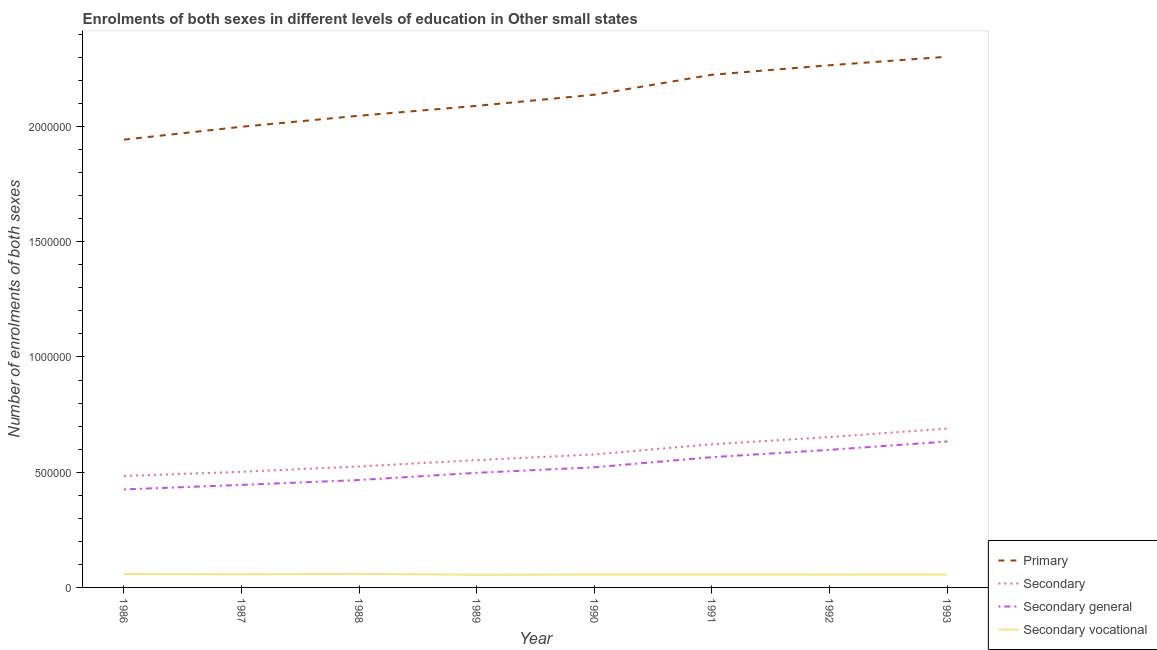Does the line corresponding to number of enrolments in primary education intersect with the line corresponding to number of enrolments in secondary education?
Your answer should be very brief. No. What is the number of enrolments in secondary education in 1989?
Your response must be concise. 5.52e+05. Across all years, what is the maximum number of enrolments in primary education?
Keep it short and to the point. 2.30e+06. Across all years, what is the minimum number of enrolments in secondary general education?
Keep it short and to the point. 4.25e+05. In which year was the number of enrolments in secondary vocational education maximum?
Your answer should be compact. 1988. What is the total number of enrolments in secondary education in the graph?
Ensure brevity in your answer.  4.60e+06. What is the difference between the number of enrolments in secondary education in 1987 and that in 1990?
Ensure brevity in your answer.  -7.55e+04. What is the difference between the number of enrolments in primary education in 1989 and the number of enrolments in secondary vocational education in 1987?
Your response must be concise. 2.03e+06. What is the average number of enrolments in secondary vocational education per year?
Your response must be concise. 5.65e+04. In the year 1988, what is the difference between the number of enrolments in primary education and number of enrolments in secondary general education?
Your answer should be compact. 1.58e+06. In how many years, is the number of enrolments in secondary education greater than 2300000?
Keep it short and to the point. 0. What is the ratio of the number of enrolments in secondary general education in 1989 to that in 1990?
Keep it short and to the point. 0.95. What is the difference between the highest and the second highest number of enrolments in primary education?
Keep it short and to the point. 3.69e+04. What is the difference between the highest and the lowest number of enrolments in secondary education?
Your response must be concise. 2.05e+05. Is it the case that in every year, the sum of the number of enrolments in secondary general education and number of enrolments in secondary education is greater than the sum of number of enrolments in primary education and number of enrolments in secondary vocational education?
Make the answer very short. No. How many lines are there?
Keep it short and to the point. 4. Are the values on the major ticks of Y-axis written in scientific E-notation?
Keep it short and to the point. No. Does the graph contain grids?
Ensure brevity in your answer.  No. How many legend labels are there?
Your answer should be very brief. 4. What is the title of the graph?
Provide a short and direct response. Enrolments of both sexes in different levels of education in Other small states. Does "Plant species" appear as one of the legend labels in the graph?
Keep it short and to the point. No. What is the label or title of the X-axis?
Keep it short and to the point. Year. What is the label or title of the Y-axis?
Keep it short and to the point. Number of enrolments of both sexes. What is the Number of enrolments of both sexes in Primary in 1986?
Your answer should be compact. 1.94e+06. What is the Number of enrolments of both sexes in Secondary in 1986?
Provide a succinct answer. 4.84e+05. What is the Number of enrolments of both sexes of Secondary general in 1986?
Provide a short and direct response. 4.25e+05. What is the Number of enrolments of both sexes in Secondary vocational in 1986?
Your answer should be compact. 5.83e+04. What is the Number of enrolments of both sexes in Primary in 1987?
Provide a short and direct response. 2.00e+06. What is the Number of enrolments of both sexes of Secondary in 1987?
Provide a short and direct response. 5.02e+05. What is the Number of enrolments of both sexes of Secondary general in 1987?
Your answer should be compact. 4.45e+05. What is the Number of enrolments of both sexes of Secondary vocational in 1987?
Your response must be concise. 5.69e+04. What is the Number of enrolments of both sexes in Primary in 1988?
Your response must be concise. 2.05e+06. What is the Number of enrolments of both sexes of Secondary in 1988?
Your answer should be compact. 5.25e+05. What is the Number of enrolments of both sexes of Secondary general in 1988?
Offer a terse response. 4.66e+05. What is the Number of enrolments of both sexes of Secondary vocational in 1988?
Provide a short and direct response. 5.89e+04. What is the Number of enrolments of both sexes in Primary in 1989?
Keep it short and to the point. 2.09e+06. What is the Number of enrolments of both sexes in Secondary in 1989?
Your response must be concise. 5.52e+05. What is the Number of enrolments of both sexes in Secondary general in 1989?
Your answer should be compact. 4.97e+05. What is the Number of enrolments of both sexes of Secondary vocational in 1989?
Your answer should be very brief. 5.49e+04. What is the Number of enrolments of both sexes in Primary in 1990?
Provide a succinct answer. 2.14e+06. What is the Number of enrolments of both sexes of Secondary in 1990?
Keep it short and to the point. 5.77e+05. What is the Number of enrolments of both sexes of Secondary general in 1990?
Your answer should be compact. 5.21e+05. What is the Number of enrolments of both sexes of Secondary vocational in 1990?
Your answer should be compact. 5.59e+04. What is the Number of enrolments of both sexes in Primary in 1991?
Provide a succinct answer. 2.22e+06. What is the Number of enrolments of both sexes in Secondary in 1991?
Offer a terse response. 6.21e+05. What is the Number of enrolments of both sexes in Secondary general in 1991?
Your answer should be compact. 5.65e+05. What is the Number of enrolments of both sexes in Secondary vocational in 1991?
Keep it short and to the point. 5.59e+04. What is the Number of enrolments of both sexes of Primary in 1992?
Your answer should be very brief. 2.27e+06. What is the Number of enrolments of both sexes in Secondary in 1992?
Keep it short and to the point. 6.53e+05. What is the Number of enrolments of both sexes of Secondary general in 1992?
Provide a short and direct response. 5.97e+05. What is the Number of enrolments of both sexes in Secondary vocational in 1992?
Offer a terse response. 5.57e+04. What is the Number of enrolments of both sexes of Primary in 1993?
Your answer should be very brief. 2.30e+06. What is the Number of enrolments of both sexes of Secondary in 1993?
Make the answer very short. 6.89e+05. What is the Number of enrolments of both sexes of Secondary general in 1993?
Your response must be concise. 6.33e+05. What is the Number of enrolments of both sexes of Secondary vocational in 1993?
Offer a very short reply. 5.59e+04. Across all years, what is the maximum Number of enrolments of both sexes in Primary?
Your answer should be compact. 2.30e+06. Across all years, what is the maximum Number of enrolments of both sexes of Secondary?
Your answer should be compact. 6.89e+05. Across all years, what is the maximum Number of enrolments of both sexes in Secondary general?
Give a very brief answer. 6.33e+05. Across all years, what is the maximum Number of enrolments of both sexes in Secondary vocational?
Give a very brief answer. 5.89e+04. Across all years, what is the minimum Number of enrolments of both sexes of Primary?
Provide a succinct answer. 1.94e+06. Across all years, what is the minimum Number of enrolments of both sexes of Secondary?
Ensure brevity in your answer.  4.84e+05. Across all years, what is the minimum Number of enrolments of both sexes of Secondary general?
Offer a terse response. 4.25e+05. Across all years, what is the minimum Number of enrolments of both sexes in Secondary vocational?
Give a very brief answer. 5.49e+04. What is the total Number of enrolments of both sexes in Primary in the graph?
Offer a very short reply. 1.70e+07. What is the total Number of enrolments of both sexes in Secondary in the graph?
Keep it short and to the point. 4.60e+06. What is the total Number of enrolments of both sexes of Secondary general in the graph?
Your response must be concise. 4.15e+06. What is the total Number of enrolments of both sexes in Secondary vocational in the graph?
Your answer should be very brief. 4.52e+05. What is the difference between the Number of enrolments of both sexes of Primary in 1986 and that in 1987?
Your answer should be very brief. -5.59e+04. What is the difference between the Number of enrolments of both sexes of Secondary in 1986 and that in 1987?
Your response must be concise. -1.81e+04. What is the difference between the Number of enrolments of both sexes in Secondary general in 1986 and that in 1987?
Give a very brief answer. -1.95e+04. What is the difference between the Number of enrolments of both sexes of Secondary vocational in 1986 and that in 1987?
Keep it short and to the point. 1404.46. What is the difference between the Number of enrolments of both sexes of Primary in 1986 and that in 1988?
Provide a short and direct response. -1.04e+05. What is the difference between the Number of enrolments of both sexes of Secondary in 1986 and that in 1988?
Keep it short and to the point. -4.14e+04. What is the difference between the Number of enrolments of both sexes of Secondary general in 1986 and that in 1988?
Ensure brevity in your answer.  -4.08e+04. What is the difference between the Number of enrolments of both sexes of Secondary vocational in 1986 and that in 1988?
Your answer should be very brief. -603.38. What is the difference between the Number of enrolments of both sexes in Primary in 1986 and that in 1989?
Provide a short and direct response. -1.47e+05. What is the difference between the Number of enrolments of both sexes of Secondary in 1986 and that in 1989?
Give a very brief answer. -6.87e+04. What is the difference between the Number of enrolments of both sexes of Secondary general in 1986 and that in 1989?
Your answer should be compact. -7.21e+04. What is the difference between the Number of enrolments of both sexes in Secondary vocational in 1986 and that in 1989?
Offer a terse response. 3339.44. What is the difference between the Number of enrolments of both sexes of Primary in 1986 and that in 1990?
Ensure brevity in your answer.  -1.95e+05. What is the difference between the Number of enrolments of both sexes of Secondary in 1986 and that in 1990?
Give a very brief answer. -9.36e+04. What is the difference between the Number of enrolments of both sexes of Secondary general in 1986 and that in 1990?
Your answer should be compact. -9.60e+04. What is the difference between the Number of enrolments of both sexes of Secondary vocational in 1986 and that in 1990?
Offer a very short reply. 2395.68. What is the difference between the Number of enrolments of both sexes in Primary in 1986 and that in 1991?
Offer a terse response. -2.82e+05. What is the difference between the Number of enrolments of both sexes in Secondary in 1986 and that in 1991?
Your response must be concise. -1.38e+05. What is the difference between the Number of enrolments of both sexes of Secondary general in 1986 and that in 1991?
Your answer should be very brief. -1.40e+05. What is the difference between the Number of enrolments of both sexes of Secondary vocational in 1986 and that in 1991?
Provide a short and direct response. 2357.86. What is the difference between the Number of enrolments of both sexes of Primary in 1986 and that in 1992?
Your answer should be very brief. -3.23e+05. What is the difference between the Number of enrolments of both sexes of Secondary in 1986 and that in 1992?
Provide a succinct answer. -1.69e+05. What is the difference between the Number of enrolments of both sexes in Secondary general in 1986 and that in 1992?
Your response must be concise. -1.72e+05. What is the difference between the Number of enrolments of both sexes of Secondary vocational in 1986 and that in 1992?
Keep it short and to the point. 2622.14. What is the difference between the Number of enrolments of both sexes of Primary in 1986 and that in 1993?
Make the answer very short. -3.60e+05. What is the difference between the Number of enrolments of both sexes in Secondary in 1986 and that in 1993?
Your response must be concise. -2.05e+05. What is the difference between the Number of enrolments of both sexes in Secondary general in 1986 and that in 1993?
Your answer should be compact. -2.08e+05. What is the difference between the Number of enrolments of both sexes in Secondary vocational in 1986 and that in 1993?
Your response must be concise. 2383.9. What is the difference between the Number of enrolments of both sexes of Primary in 1987 and that in 1988?
Provide a short and direct response. -4.79e+04. What is the difference between the Number of enrolments of both sexes in Secondary in 1987 and that in 1988?
Make the answer very short. -2.33e+04. What is the difference between the Number of enrolments of both sexes of Secondary general in 1987 and that in 1988?
Offer a very short reply. -2.13e+04. What is the difference between the Number of enrolments of both sexes in Secondary vocational in 1987 and that in 1988?
Make the answer very short. -2007.84. What is the difference between the Number of enrolments of both sexes of Primary in 1987 and that in 1989?
Give a very brief answer. -9.08e+04. What is the difference between the Number of enrolments of both sexes of Secondary in 1987 and that in 1989?
Make the answer very short. -5.06e+04. What is the difference between the Number of enrolments of both sexes in Secondary general in 1987 and that in 1989?
Offer a very short reply. -5.25e+04. What is the difference between the Number of enrolments of both sexes in Secondary vocational in 1987 and that in 1989?
Your answer should be very brief. 1934.98. What is the difference between the Number of enrolments of both sexes of Primary in 1987 and that in 1990?
Keep it short and to the point. -1.39e+05. What is the difference between the Number of enrolments of both sexes of Secondary in 1987 and that in 1990?
Provide a short and direct response. -7.55e+04. What is the difference between the Number of enrolments of both sexes of Secondary general in 1987 and that in 1990?
Keep it short and to the point. -7.65e+04. What is the difference between the Number of enrolments of both sexes of Secondary vocational in 1987 and that in 1990?
Offer a very short reply. 991.21. What is the difference between the Number of enrolments of both sexes of Primary in 1987 and that in 1991?
Provide a succinct answer. -2.26e+05. What is the difference between the Number of enrolments of both sexes in Secondary in 1987 and that in 1991?
Offer a very short reply. -1.19e+05. What is the difference between the Number of enrolments of both sexes in Secondary general in 1987 and that in 1991?
Provide a short and direct response. -1.20e+05. What is the difference between the Number of enrolments of both sexes in Secondary vocational in 1987 and that in 1991?
Keep it short and to the point. 953.4. What is the difference between the Number of enrolments of both sexes in Primary in 1987 and that in 1992?
Offer a terse response. -2.67e+05. What is the difference between the Number of enrolments of both sexes in Secondary in 1987 and that in 1992?
Offer a very short reply. -1.51e+05. What is the difference between the Number of enrolments of both sexes of Secondary general in 1987 and that in 1992?
Keep it short and to the point. -1.52e+05. What is the difference between the Number of enrolments of both sexes in Secondary vocational in 1987 and that in 1992?
Provide a succinct answer. 1217.68. What is the difference between the Number of enrolments of both sexes of Primary in 1987 and that in 1993?
Offer a very short reply. -3.04e+05. What is the difference between the Number of enrolments of both sexes of Secondary in 1987 and that in 1993?
Your answer should be compact. -1.87e+05. What is the difference between the Number of enrolments of both sexes in Secondary general in 1987 and that in 1993?
Your answer should be compact. -1.88e+05. What is the difference between the Number of enrolments of both sexes of Secondary vocational in 1987 and that in 1993?
Your answer should be compact. 979.44. What is the difference between the Number of enrolments of both sexes of Primary in 1988 and that in 1989?
Offer a very short reply. -4.29e+04. What is the difference between the Number of enrolments of both sexes in Secondary in 1988 and that in 1989?
Keep it short and to the point. -2.73e+04. What is the difference between the Number of enrolments of both sexes in Secondary general in 1988 and that in 1989?
Provide a short and direct response. -3.13e+04. What is the difference between the Number of enrolments of both sexes of Secondary vocational in 1988 and that in 1989?
Make the answer very short. 3942.82. What is the difference between the Number of enrolments of both sexes in Primary in 1988 and that in 1990?
Offer a very short reply. -9.12e+04. What is the difference between the Number of enrolments of both sexes in Secondary in 1988 and that in 1990?
Provide a succinct answer. -5.22e+04. What is the difference between the Number of enrolments of both sexes of Secondary general in 1988 and that in 1990?
Provide a short and direct response. -5.52e+04. What is the difference between the Number of enrolments of both sexes of Secondary vocational in 1988 and that in 1990?
Ensure brevity in your answer.  2999.05. What is the difference between the Number of enrolments of both sexes in Primary in 1988 and that in 1991?
Ensure brevity in your answer.  -1.78e+05. What is the difference between the Number of enrolments of both sexes in Secondary in 1988 and that in 1991?
Provide a short and direct response. -9.62e+04. What is the difference between the Number of enrolments of both sexes in Secondary general in 1988 and that in 1991?
Offer a terse response. -9.92e+04. What is the difference between the Number of enrolments of both sexes in Secondary vocational in 1988 and that in 1991?
Your answer should be very brief. 2961.24. What is the difference between the Number of enrolments of both sexes in Primary in 1988 and that in 1992?
Offer a terse response. -2.19e+05. What is the difference between the Number of enrolments of both sexes in Secondary in 1988 and that in 1992?
Make the answer very short. -1.28e+05. What is the difference between the Number of enrolments of both sexes of Secondary general in 1988 and that in 1992?
Your answer should be very brief. -1.31e+05. What is the difference between the Number of enrolments of both sexes of Secondary vocational in 1988 and that in 1992?
Your answer should be very brief. 3225.52. What is the difference between the Number of enrolments of both sexes of Primary in 1988 and that in 1993?
Ensure brevity in your answer.  -2.56e+05. What is the difference between the Number of enrolments of both sexes in Secondary in 1988 and that in 1993?
Provide a succinct answer. -1.64e+05. What is the difference between the Number of enrolments of both sexes in Secondary general in 1988 and that in 1993?
Make the answer very short. -1.67e+05. What is the difference between the Number of enrolments of both sexes of Secondary vocational in 1988 and that in 1993?
Ensure brevity in your answer.  2987.28. What is the difference between the Number of enrolments of both sexes in Primary in 1989 and that in 1990?
Give a very brief answer. -4.83e+04. What is the difference between the Number of enrolments of both sexes in Secondary in 1989 and that in 1990?
Your answer should be compact. -2.49e+04. What is the difference between the Number of enrolments of both sexes of Secondary general in 1989 and that in 1990?
Your response must be concise. -2.39e+04. What is the difference between the Number of enrolments of both sexes of Secondary vocational in 1989 and that in 1990?
Your answer should be compact. -943.76. What is the difference between the Number of enrolments of both sexes of Primary in 1989 and that in 1991?
Make the answer very short. -1.35e+05. What is the difference between the Number of enrolments of both sexes in Secondary in 1989 and that in 1991?
Your answer should be very brief. -6.89e+04. What is the difference between the Number of enrolments of both sexes in Secondary general in 1989 and that in 1991?
Provide a succinct answer. -6.79e+04. What is the difference between the Number of enrolments of both sexes in Secondary vocational in 1989 and that in 1991?
Make the answer very short. -981.58. What is the difference between the Number of enrolments of both sexes in Primary in 1989 and that in 1992?
Offer a very short reply. -1.76e+05. What is the difference between the Number of enrolments of both sexes in Secondary in 1989 and that in 1992?
Offer a terse response. -1.00e+05. What is the difference between the Number of enrolments of both sexes of Secondary general in 1989 and that in 1992?
Provide a succinct answer. -9.96e+04. What is the difference between the Number of enrolments of both sexes of Secondary vocational in 1989 and that in 1992?
Provide a short and direct response. -717.3. What is the difference between the Number of enrolments of both sexes in Primary in 1989 and that in 1993?
Offer a terse response. -2.13e+05. What is the difference between the Number of enrolments of both sexes of Secondary in 1989 and that in 1993?
Offer a terse response. -1.37e+05. What is the difference between the Number of enrolments of both sexes in Secondary general in 1989 and that in 1993?
Keep it short and to the point. -1.36e+05. What is the difference between the Number of enrolments of both sexes of Secondary vocational in 1989 and that in 1993?
Your response must be concise. -955.54. What is the difference between the Number of enrolments of both sexes of Primary in 1990 and that in 1991?
Provide a short and direct response. -8.66e+04. What is the difference between the Number of enrolments of both sexes in Secondary in 1990 and that in 1991?
Provide a short and direct response. -4.40e+04. What is the difference between the Number of enrolments of both sexes in Secondary general in 1990 and that in 1991?
Ensure brevity in your answer.  -4.40e+04. What is the difference between the Number of enrolments of both sexes of Secondary vocational in 1990 and that in 1991?
Provide a succinct answer. -37.82. What is the difference between the Number of enrolments of both sexes in Primary in 1990 and that in 1992?
Provide a short and direct response. -1.28e+05. What is the difference between the Number of enrolments of both sexes of Secondary in 1990 and that in 1992?
Give a very brief answer. -7.55e+04. What is the difference between the Number of enrolments of both sexes of Secondary general in 1990 and that in 1992?
Offer a very short reply. -7.57e+04. What is the difference between the Number of enrolments of both sexes in Secondary vocational in 1990 and that in 1992?
Offer a terse response. 226.46. What is the difference between the Number of enrolments of both sexes of Primary in 1990 and that in 1993?
Give a very brief answer. -1.65e+05. What is the difference between the Number of enrolments of both sexes of Secondary in 1990 and that in 1993?
Give a very brief answer. -1.12e+05. What is the difference between the Number of enrolments of both sexes of Secondary general in 1990 and that in 1993?
Your answer should be compact. -1.12e+05. What is the difference between the Number of enrolments of both sexes in Secondary vocational in 1990 and that in 1993?
Provide a succinct answer. -11.78. What is the difference between the Number of enrolments of both sexes in Primary in 1991 and that in 1992?
Provide a succinct answer. -4.13e+04. What is the difference between the Number of enrolments of both sexes in Secondary in 1991 and that in 1992?
Keep it short and to the point. -3.14e+04. What is the difference between the Number of enrolments of both sexes of Secondary general in 1991 and that in 1992?
Your response must be concise. -3.17e+04. What is the difference between the Number of enrolments of both sexes in Secondary vocational in 1991 and that in 1992?
Make the answer very short. 264.28. What is the difference between the Number of enrolments of both sexes in Primary in 1991 and that in 1993?
Keep it short and to the point. -7.82e+04. What is the difference between the Number of enrolments of both sexes in Secondary in 1991 and that in 1993?
Your answer should be compact. -6.79e+04. What is the difference between the Number of enrolments of both sexes in Secondary general in 1991 and that in 1993?
Give a very brief answer. -6.79e+04. What is the difference between the Number of enrolments of both sexes of Secondary vocational in 1991 and that in 1993?
Offer a terse response. 26.04. What is the difference between the Number of enrolments of both sexes of Primary in 1992 and that in 1993?
Make the answer very short. -3.69e+04. What is the difference between the Number of enrolments of both sexes in Secondary in 1992 and that in 1993?
Offer a very short reply. -3.64e+04. What is the difference between the Number of enrolments of both sexes of Secondary general in 1992 and that in 1993?
Your answer should be compact. -3.62e+04. What is the difference between the Number of enrolments of both sexes of Secondary vocational in 1992 and that in 1993?
Your answer should be compact. -238.24. What is the difference between the Number of enrolments of both sexes in Primary in 1986 and the Number of enrolments of both sexes in Secondary in 1987?
Offer a terse response. 1.44e+06. What is the difference between the Number of enrolments of both sexes in Primary in 1986 and the Number of enrolments of both sexes in Secondary general in 1987?
Your answer should be very brief. 1.50e+06. What is the difference between the Number of enrolments of both sexes of Primary in 1986 and the Number of enrolments of both sexes of Secondary vocational in 1987?
Provide a succinct answer. 1.89e+06. What is the difference between the Number of enrolments of both sexes of Secondary in 1986 and the Number of enrolments of both sexes of Secondary general in 1987?
Ensure brevity in your answer.  3.88e+04. What is the difference between the Number of enrolments of both sexes in Secondary in 1986 and the Number of enrolments of both sexes in Secondary vocational in 1987?
Give a very brief answer. 4.27e+05. What is the difference between the Number of enrolments of both sexes of Secondary general in 1986 and the Number of enrolments of both sexes of Secondary vocational in 1987?
Ensure brevity in your answer.  3.68e+05. What is the difference between the Number of enrolments of both sexes of Primary in 1986 and the Number of enrolments of both sexes of Secondary in 1988?
Provide a succinct answer. 1.42e+06. What is the difference between the Number of enrolments of both sexes in Primary in 1986 and the Number of enrolments of both sexes in Secondary general in 1988?
Keep it short and to the point. 1.48e+06. What is the difference between the Number of enrolments of both sexes of Primary in 1986 and the Number of enrolments of both sexes of Secondary vocational in 1988?
Give a very brief answer. 1.88e+06. What is the difference between the Number of enrolments of both sexes in Secondary in 1986 and the Number of enrolments of both sexes in Secondary general in 1988?
Keep it short and to the point. 1.75e+04. What is the difference between the Number of enrolments of both sexes in Secondary in 1986 and the Number of enrolments of both sexes in Secondary vocational in 1988?
Make the answer very short. 4.25e+05. What is the difference between the Number of enrolments of both sexes in Secondary general in 1986 and the Number of enrolments of both sexes in Secondary vocational in 1988?
Keep it short and to the point. 3.66e+05. What is the difference between the Number of enrolments of both sexes in Primary in 1986 and the Number of enrolments of both sexes in Secondary in 1989?
Offer a very short reply. 1.39e+06. What is the difference between the Number of enrolments of both sexes in Primary in 1986 and the Number of enrolments of both sexes in Secondary general in 1989?
Provide a short and direct response. 1.45e+06. What is the difference between the Number of enrolments of both sexes in Primary in 1986 and the Number of enrolments of both sexes in Secondary vocational in 1989?
Offer a very short reply. 1.89e+06. What is the difference between the Number of enrolments of both sexes of Secondary in 1986 and the Number of enrolments of both sexes of Secondary general in 1989?
Provide a succinct answer. -1.38e+04. What is the difference between the Number of enrolments of both sexes in Secondary in 1986 and the Number of enrolments of both sexes in Secondary vocational in 1989?
Offer a very short reply. 4.29e+05. What is the difference between the Number of enrolments of both sexes of Secondary general in 1986 and the Number of enrolments of both sexes of Secondary vocational in 1989?
Your response must be concise. 3.70e+05. What is the difference between the Number of enrolments of both sexes of Primary in 1986 and the Number of enrolments of both sexes of Secondary in 1990?
Ensure brevity in your answer.  1.37e+06. What is the difference between the Number of enrolments of both sexes in Primary in 1986 and the Number of enrolments of both sexes in Secondary general in 1990?
Keep it short and to the point. 1.42e+06. What is the difference between the Number of enrolments of both sexes of Primary in 1986 and the Number of enrolments of both sexes of Secondary vocational in 1990?
Offer a very short reply. 1.89e+06. What is the difference between the Number of enrolments of both sexes in Secondary in 1986 and the Number of enrolments of both sexes in Secondary general in 1990?
Provide a succinct answer. -3.77e+04. What is the difference between the Number of enrolments of both sexes of Secondary in 1986 and the Number of enrolments of both sexes of Secondary vocational in 1990?
Provide a short and direct response. 4.28e+05. What is the difference between the Number of enrolments of both sexes in Secondary general in 1986 and the Number of enrolments of both sexes in Secondary vocational in 1990?
Offer a terse response. 3.69e+05. What is the difference between the Number of enrolments of both sexes of Primary in 1986 and the Number of enrolments of both sexes of Secondary in 1991?
Keep it short and to the point. 1.32e+06. What is the difference between the Number of enrolments of both sexes of Primary in 1986 and the Number of enrolments of both sexes of Secondary general in 1991?
Provide a succinct answer. 1.38e+06. What is the difference between the Number of enrolments of both sexes of Primary in 1986 and the Number of enrolments of both sexes of Secondary vocational in 1991?
Offer a terse response. 1.89e+06. What is the difference between the Number of enrolments of both sexes in Secondary in 1986 and the Number of enrolments of both sexes in Secondary general in 1991?
Keep it short and to the point. -8.17e+04. What is the difference between the Number of enrolments of both sexes of Secondary in 1986 and the Number of enrolments of both sexes of Secondary vocational in 1991?
Offer a terse response. 4.28e+05. What is the difference between the Number of enrolments of both sexes in Secondary general in 1986 and the Number of enrolments of both sexes in Secondary vocational in 1991?
Make the answer very short. 3.69e+05. What is the difference between the Number of enrolments of both sexes of Primary in 1986 and the Number of enrolments of both sexes of Secondary in 1992?
Make the answer very short. 1.29e+06. What is the difference between the Number of enrolments of both sexes in Primary in 1986 and the Number of enrolments of both sexes in Secondary general in 1992?
Your answer should be compact. 1.35e+06. What is the difference between the Number of enrolments of both sexes in Primary in 1986 and the Number of enrolments of both sexes in Secondary vocational in 1992?
Ensure brevity in your answer.  1.89e+06. What is the difference between the Number of enrolments of both sexes in Secondary in 1986 and the Number of enrolments of both sexes in Secondary general in 1992?
Keep it short and to the point. -1.13e+05. What is the difference between the Number of enrolments of both sexes in Secondary in 1986 and the Number of enrolments of both sexes in Secondary vocational in 1992?
Your response must be concise. 4.28e+05. What is the difference between the Number of enrolments of both sexes in Secondary general in 1986 and the Number of enrolments of both sexes in Secondary vocational in 1992?
Keep it short and to the point. 3.70e+05. What is the difference between the Number of enrolments of both sexes of Primary in 1986 and the Number of enrolments of both sexes of Secondary in 1993?
Offer a terse response. 1.25e+06. What is the difference between the Number of enrolments of both sexes of Primary in 1986 and the Number of enrolments of both sexes of Secondary general in 1993?
Offer a terse response. 1.31e+06. What is the difference between the Number of enrolments of both sexes of Primary in 1986 and the Number of enrolments of both sexes of Secondary vocational in 1993?
Provide a succinct answer. 1.89e+06. What is the difference between the Number of enrolments of both sexes in Secondary in 1986 and the Number of enrolments of both sexes in Secondary general in 1993?
Make the answer very short. -1.50e+05. What is the difference between the Number of enrolments of both sexes in Secondary in 1986 and the Number of enrolments of both sexes in Secondary vocational in 1993?
Offer a terse response. 4.28e+05. What is the difference between the Number of enrolments of both sexes of Secondary general in 1986 and the Number of enrolments of both sexes of Secondary vocational in 1993?
Offer a very short reply. 3.69e+05. What is the difference between the Number of enrolments of both sexes of Primary in 1987 and the Number of enrolments of both sexes of Secondary in 1988?
Provide a short and direct response. 1.47e+06. What is the difference between the Number of enrolments of both sexes in Primary in 1987 and the Number of enrolments of both sexes in Secondary general in 1988?
Keep it short and to the point. 1.53e+06. What is the difference between the Number of enrolments of both sexes in Primary in 1987 and the Number of enrolments of both sexes in Secondary vocational in 1988?
Your response must be concise. 1.94e+06. What is the difference between the Number of enrolments of both sexes of Secondary in 1987 and the Number of enrolments of both sexes of Secondary general in 1988?
Offer a very short reply. 3.56e+04. What is the difference between the Number of enrolments of both sexes of Secondary in 1987 and the Number of enrolments of both sexes of Secondary vocational in 1988?
Give a very brief answer. 4.43e+05. What is the difference between the Number of enrolments of both sexes of Secondary general in 1987 and the Number of enrolments of both sexes of Secondary vocational in 1988?
Your answer should be compact. 3.86e+05. What is the difference between the Number of enrolments of both sexes of Primary in 1987 and the Number of enrolments of both sexes of Secondary in 1989?
Your response must be concise. 1.45e+06. What is the difference between the Number of enrolments of both sexes in Primary in 1987 and the Number of enrolments of both sexes in Secondary general in 1989?
Make the answer very short. 1.50e+06. What is the difference between the Number of enrolments of both sexes of Primary in 1987 and the Number of enrolments of both sexes of Secondary vocational in 1989?
Your answer should be very brief. 1.94e+06. What is the difference between the Number of enrolments of both sexes of Secondary in 1987 and the Number of enrolments of both sexes of Secondary general in 1989?
Offer a very short reply. 4329.91. What is the difference between the Number of enrolments of both sexes in Secondary in 1987 and the Number of enrolments of both sexes in Secondary vocational in 1989?
Your answer should be compact. 4.47e+05. What is the difference between the Number of enrolments of both sexes of Secondary general in 1987 and the Number of enrolments of both sexes of Secondary vocational in 1989?
Your answer should be very brief. 3.90e+05. What is the difference between the Number of enrolments of both sexes of Primary in 1987 and the Number of enrolments of both sexes of Secondary in 1990?
Your response must be concise. 1.42e+06. What is the difference between the Number of enrolments of both sexes of Primary in 1987 and the Number of enrolments of both sexes of Secondary general in 1990?
Ensure brevity in your answer.  1.48e+06. What is the difference between the Number of enrolments of both sexes of Primary in 1987 and the Number of enrolments of both sexes of Secondary vocational in 1990?
Offer a very short reply. 1.94e+06. What is the difference between the Number of enrolments of both sexes of Secondary in 1987 and the Number of enrolments of both sexes of Secondary general in 1990?
Give a very brief answer. -1.96e+04. What is the difference between the Number of enrolments of both sexes of Secondary in 1987 and the Number of enrolments of both sexes of Secondary vocational in 1990?
Provide a succinct answer. 4.46e+05. What is the difference between the Number of enrolments of both sexes of Secondary general in 1987 and the Number of enrolments of both sexes of Secondary vocational in 1990?
Give a very brief answer. 3.89e+05. What is the difference between the Number of enrolments of both sexes of Primary in 1987 and the Number of enrolments of both sexes of Secondary in 1991?
Your answer should be very brief. 1.38e+06. What is the difference between the Number of enrolments of both sexes of Primary in 1987 and the Number of enrolments of both sexes of Secondary general in 1991?
Give a very brief answer. 1.43e+06. What is the difference between the Number of enrolments of both sexes in Primary in 1987 and the Number of enrolments of both sexes in Secondary vocational in 1991?
Ensure brevity in your answer.  1.94e+06. What is the difference between the Number of enrolments of both sexes in Secondary in 1987 and the Number of enrolments of both sexes in Secondary general in 1991?
Give a very brief answer. -6.36e+04. What is the difference between the Number of enrolments of both sexes in Secondary in 1987 and the Number of enrolments of both sexes in Secondary vocational in 1991?
Give a very brief answer. 4.46e+05. What is the difference between the Number of enrolments of both sexes in Secondary general in 1987 and the Number of enrolments of both sexes in Secondary vocational in 1991?
Offer a very short reply. 3.89e+05. What is the difference between the Number of enrolments of both sexes of Primary in 1987 and the Number of enrolments of both sexes of Secondary in 1992?
Offer a very short reply. 1.35e+06. What is the difference between the Number of enrolments of both sexes in Primary in 1987 and the Number of enrolments of both sexes in Secondary general in 1992?
Provide a short and direct response. 1.40e+06. What is the difference between the Number of enrolments of both sexes of Primary in 1987 and the Number of enrolments of both sexes of Secondary vocational in 1992?
Offer a very short reply. 1.94e+06. What is the difference between the Number of enrolments of both sexes of Secondary in 1987 and the Number of enrolments of both sexes of Secondary general in 1992?
Offer a terse response. -9.53e+04. What is the difference between the Number of enrolments of both sexes of Secondary in 1987 and the Number of enrolments of both sexes of Secondary vocational in 1992?
Offer a very short reply. 4.46e+05. What is the difference between the Number of enrolments of both sexes of Secondary general in 1987 and the Number of enrolments of both sexes of Secondary vocational in 1992?
Make the answer very short. 3.89e+05. What is the difference between the Number of enrolments of both sexes of Primary in 1987 and the Number of enrolments of both sexes of Secondary in 1993?
Give a very brief answer. 1.31e+06. What is the difference between the Number of enrolments of both sexes in Primary in 1987 and the Number of enrolments of both sexes in Secondary general in 1993?
Ensure brevity in your answer.  1.37e+06. What is the difference between the Number of enrolments of both sexes of Primary in 1987 and the Number of enrolments of both sexes of Secondary vocational in 1993?
Make the answer very short. 1.94e+06. What is the difference between the Number of enrolments of both sexes of Secondary in 1987 and the Number of enrolments of both sexes of Secondary general in 1993?
Offer a terse response. -1.31e+05. What is the difference between the Number of enrolments of both sexes of Secondary in 1987 and the Number of enrolments of both sexes of Secondary vocational in 1993?
Provide a short and direct response. 4.46e+05. What is the difference between the Number of enrolments of both sexes of Secondary general in 1987 and the Number of enrolments of both sexes of Secondary vocational in 1993?
Offer a terse response. 3.89e+05. What is the difference between the Number of enrolments of both sexes in Primary in 1988 and the Number of enrolments of both sexes in Secondary in 1989?
Ensure brevity in your answer.  1.49e+06. What is the difference between the Number of enrolments of both sexes in Primary in 1988 and the Number of enrolments of both sexes in Secondary general in 1989?
Offer a terse response. 1.55e+06. What is the difference between the Number of enrolments of both sexes of Primary in 1988 and the Number of enrolments of both sexes of Secondary vocational in 1989?
Ensure brevity in your answer.  1.99e+06. What is the difference between the Number of enrolments of both sexes of Secondary in 1988 and the Number of enrolments of both sexes of Secondary general in 1989?
Provide a succinct answer. 2.76e+04. What is the difference between the Number of enrolments of both sexes in Secondary in 1988 and the Number of enrolments of both sexes in Secondary vocational in 1989?
Provide a short and direct response. 4.70e+05. What is the difference between the Number of enrolments of both sexes of Secondary general in 1988 and the Number of enrolments of both sexes of Secondary vocational in 1989?
Your response must be concise. 4.11e+05. What is the difference between the Number of enrolments of both sexes of Primary in 1988 and the Number of enrolments of both sexes of Secondary in 1990?
Your response must be concise. 1.47e+06. What is the difference between the Number of enrolments of both sexes in Primary in 1988 and the Number of enrolments of both sexes in Secondary general in 1990?
Offer a terse response. 1.53e+06. What is the difference between the Number of enrolments of both sexes in Primary in 1988 and the Number of enrolments of both sexes in Secondary vocational in 1990?
Your answer should be compact. 1.99e+06. What is the difference between the Number of enrolments of both sexes in Secondary in 1988 and the Number of enrolments of both sexes in Secondary general in 1990?
Ensure brevity in your answer.  3676.78. What is the difference between the Number of enrolments of both sexes in Secondary in 1988 and the Number of enrolments of both sexes in Secondary vocational in 1990?
Provide a succinct answer. 4.69e+05. What is the difference between the Number of enrolments of both sexes of Secondary general in 1988 and the Number of enrolments of both sexes of Secondary vocational in 1990?
Your answer should be very brief. 4.10e+05. What is the difference between the Number of enrolments of both sexes of Primary in 1988 and the Number of enrolments of both sexes of Secondary in 1991?
Your answer should be compact. 1.43e+06. What is the difference between the Number of enrolments of both sexes of Primary in 1988 and the Number of enrolments of both sexes of Secondary general in 1991?
Give a very brief answer. 1.48e+06. What is the difference between the Number of enrolments of both sexes in Primary in 1988 and the Number of enrolments of both sexes in Secondary vocational in 1991?
Make the answer very short. 1.99e+06. What is the difference between the Number of enrolments of both sexes in Secondary in 1988 and the Number of enrolments of both sexes in Secondary general in 1991?
Offer a very short reply. -4.03e+04. What is the difference between the Number of enrolments of both sexes in Secondary in 1988 and the Number of enrolments of both sexes in Secondary vocational in 1991?
Give a very brief answer. 4.69e+05. What is the difference between the Number of enrolments of both sexes in Secondary general in 1988 and the Number of enrolments of both sexes in Secondary vocational in 1991?
Give a very brief answer. 4.10e+05. What is the difference between the Number of enrolments of both sexes in Primary in 1988 and the Number of enrolments of both sexes in Secondary in 1992?
Ensure brevity in your answer.  1.39e+06. What is the difference between the Number of enrolments of both sexes of Primary in 1988 and the Number of enrolments of both sexes of Secondary general in 1992?
Provide a succinct answer. 1.45e+06. What is the difference between the Number of enrolments of both sexes of Primary in 1988 and the Number of enrolments of both sexes of Secondary vocational in 1992?
Keep it short and to the point. 1.99e+06. What is the difference between the Number of enrolments of both sexes of Secondary in 1988 and the Number of enrolments of both sexes of Secondary general in 1992?
Make the answer very short. -7.20e+04. What is the difference between the Number of enrolments of both sexes of Secondary in 1988 and the Number of enrolments of both sexes of Secondary vocational in 1992?
Offer a terse response. 4.69e+05. What is the difference between the Number of enrolments of both sexes of Secondary general in 1988 and the Number of enrolments of both sexes of Secondary vocational in 1992?
Your answer should be very brief. 4.10e+05. What is the difference between the Number of enrolments of both sexes in Primary in 1988 and the Number of enrolments of both sexes in Secondary in 1993?
Your answer should be compact. 1.36e+06. What is the difference between the Number of enrolments of both sexes of Primary in 1988 and the Number of enrolments of both sexes of Secondary general in 1993?
Offer a terse response. 1.41e+06. What is the difference between the Number of enrolments of both sexes of Primary in 1988 and the Number of enrolments of both sexes of Secondary vocational in 1993?
Offer a terse response. 1.99e+06. What is the difference between the Number of enrolments of both sexes in Secondary in 1988 and the Number of enrolments of both sexes in Secondary general in 1993?
Your answer should be very brief. -1.08e+05. What is the difference between the Number of enrolments of both sexes of Secondary in 1988 and the Number of enrolments of both sexes of Secondary vocational in 1993?
Offer a terse response. 4.69e+05. What is the difference between the Number of enrolments of both sexes in Secondary general in 1988 and the Number of enrolments of both sexes in Secondary vocational in 1993?
Ensure brevity in your answer.  4.10e+05. What is the difference between the Number of enrolments of both sexes in Primary in 1989 and the Number of enrolments of both sexes in Secondary in 1990?
Ensure brevity in your answer.  1.51e+06. What is the difference between the Number of enrolments of both sexes in Primary in 1989 and the Number of enrolments of both sexes in Secondary general in 1990?
Make the answer very short. 1.57e+06. What is the difference between the Number of enrolments of both sexes in Primary in 1989 and the Number of enrolments of both sexes in Secondary vocational in 1990?
Make the answer very short. 2.03e+06. What is the difference between the Number of enrolments of both sexes in Secondary in 1989 and the Number of enrolments of both sexes in Secondary general in 1990?
Keep it short and to the point. 3.10e+04. What is the difference between the Number of enrolments of both sexes of Secondary in 1989 and the Number of enrolments of both sexes of Secondary vocational in 1990?
Offer a very short reply. 4.96e+05. What is the difference between the Number of enrolments of both sexes in Secondary general in 1989 and the Number of enrolments of both sexes in Secondary vocational in 1990?
Ensure brevity in your answer.  4.41e+05. What is the difference between the Number of enrolments of both sexes in Primary in 1989 and the Number of enrolments of both sexes in Secondary in 1991?
Offer a very short reply. 1.47e+06. What is the difference between the Number of enrolments of both sexes of Primary in 1989 and the Number of enrolments of both sexes of Secondary general in 1991?
Provide a short and direct response. 1.52e+06. What is the difference between the Number of enrolments of both sexes of Primary in 1989 and the Number of enrolments of both sexes of Secondary vocational in 1991?
Keep it short and to the point. 2.03e+06. What is the difference between the Number of enrolments of both sexes of Secondary in 1989 and the Number of enrolments of both sexes of Secondary general in 1991?
Your answer should be very brief. -1.29e+04. What is the difference between the Number of enrolments of both sexes of Secondary in 1989 and the Number of enrolments of both sexes of Secondary vocational in 1991?
Ensure brevity in your answer.  4.96e+05. What is the difference between the Number of enrolments of both sexes of Secondary general in 1989 and the Number of enrolments of both sexes of Secondary vocational in 1991?
Make the answer very short. 4.41e+05. What is the difference between the Number of enrolments of both sexes of Primary in 1989 and the Number of enrolments of both sexes of Secondary in 1992?
Offer a terse response. 1.44e+06. What is the difference between the Number of enrolments of both sexes of Primary in 1989 and the Number of enrolments of both sexes of Secondary general in 1992?
Your answer should be compact. 1.49e+06. What is the difference between the Number of enrolments of both sexes in Primary in 1989 and the Number of enrolments of both sexes in Secondary vocational in 1992?
Your response must be concise. 2.03e+06. What is the difference between the Number of enrolments of both sexes in Secondary in 1989 and the Number of enrolments of both sexes in Secondary general in 1992?
Make the answer very short. -4.47e+04. What is the difference between the Number of enrolments of both sexes in Secondary in 1989 and the Number of enrolments of both sexes in Secondary vocational in 1992?
Offer a very short reply. 4.97e+05. What is the difference between the Number of enrolments of both sexes of Secondary general in 1989 and the Number of enrolments of both sexes of Secondary vocational in 1992?
Your answer should be very brief. 4.42e+05. What is the difference between the Number of enrolments of both sexes in Primary in 1989 and the Number of enrolments of both sexes in Secondary in 1993?
Ensure brevity in your answer.  1.40e+06. What is the difference between the Number of enrolments of both sexes of Primary in 1989 and the Number of enrolments of both sexes of Secondary general in 1993?
Offer a terse response. 1.46e+06. What is the difference between the Number of enrolments of both sexes in Primary in 1989 and the Number of enrolments of both sexes in Secondary vocational in 1993?
Offer a very short reply. 2.03e+06. What is the difference between the Number of enrolments of both sexes in Secondary in 1989 and the Number of enrolments of both sexes in Secondary general in 1993?
Your answer should be compact. -8.08e+04. What is the difference between the Number of enrolments of both sexes in Secondary in 1989 and the Number of enrolments of both sexes in Secondary vocational in 1993?
Keep it short and to the point. 4.96e+05. What is the difference between the Number of enrolments of both sexes in Secondary general in 1989 and the Number of enrolments of both sexes in Secondary vocational in 1993?
Offer a very short reply. 4.41e+05. What is the difference between the Number of enrolments of both sexes in Primary in 1990 and the Number of enrolments of both sexes in Secondary in 1991?
Provide a succinct answer. 1.52e+06. What is the difference between the Number of enrolments of both sexes of Primary in 1990 and the Number of enrolments of both sexes of Secondary general in 1991?
Give a very brief answer. 1.57e+06. What is the difference between the Number of enrolments of both sexes in Primary in 1990 and the Number of enrolments of both sexes in Secondary vocational in 1991?
Offer a terse response. 2.08e+06. What is the difference between the Number of enrolments of both sexes of Secondary in 1990 and the Number of enrolments of both sexes of Secondary general in 1991?
Keep it short and to the point. 1.19e+04. What is the difference between the Number of enrolments of both sexes in Secondary in 1990 and the Number of enrolments of both sexes in Secondary vocational in 1991?
Ensure brevity in your answer.  5.21e+05. What is the difference between the Number of enrolments of both sexes of Secondary general in 1990 and the Number of enrolments of both sexes of Secondary vocational in 1991?
Your answer should be compact. 4.65e+05. What is the difference between the Number of enrolments of both sexes of Primary in 1990 and the Number of enrolments of both sexes of Secondary in 1992?
Offer a terse response. 1.49e+06. What is the difference between the Number of enrolments of both sexes in Primary in 1990 and the Number of enrolments of both sexes in Secondary general in 1992?
Provide a succinct answer. 1.54e+06. What is the difference between the Number of enrolments of both sexes of Primary in 1990 and the Number of enrolments of both sexes of Secondary vocational in 1992?
Your answer should be compact. 2.08e+06. What is the difference between the Number of enrolments of both sexes of Secondary in 1990 and the Number of enrolments of both sexes of Secondary general in 1992?
Keep it short and to the point. -1.98e+04. What is the difference between the Number of enrolments of both sexes in Secondary in 1990 and the Number of enrolments of both sexes in Secondary vocational in 1992?
Offer a terse response. 5.22e+05. What is the difference between the Number of enrolments of both sexes of Secondary general in 1990 and the Number of enrolments of both sexes of Secondary vocational in 1992?
Ensure brevity in your answer.  4.66e+05. What is the difference between the Number of enrolments of both sexes in Primary in 1990 and the Number of enrolments of both sexes in Secondary in 1993?
Provide a short and direct response. 1.45e+06. What is the difference between the Number of enrolments of both sexes in Primary in 1990 and the Number of enrolments of both sexes in Secondary general in 1993?
Offer a very short reply. 1.50e+06. What is the difference between the Number of enrolments of both sexes in Primary in 1990 and the Number of enrolments of both sexes in Secondary vocational in 1993?
Offer a very short reply. 2.08e+06. What is the difference between the Number of enrolments of both sexes of Secondary in 1990 and the Number of enrolments of both sexes of Secondary general in 1993?
Your answer should be very brief. -5.60e+04. What is the difference between the Number of enrolments of both sexes in Secondary in 1990 and the Number of enrolments of both sexes in Secondary vocational in 1993?
Ensure brevity in your answer.  5.21e+05. What is the difference between the Number of enrolments of both sexes in Secondary general in 1990 and the Number of enrolments of both sexes in Secondary vocational in 1993?
Your answer should be very brief. 4.65e+05. What is the difference between the Number of enrolments of both sexes of Primary in 1991 and the Number of enrolments of both sexes of Secondary in 1992?
Your response must be concise. 1.57e+06. What is the difference between the Number of enrolments of both sexes of Primary in 1991 and the Number of enrolments of both sexes of Secondary general in 1992?
Your response must be concise. 1.63e+06. What is the difference between the Number of enrolments of both sexes in Primary in 1991 and the Number of enrolments of both sexes in Secondary vocational in 1992?
Offer a very short reply. 2.17e+06. What is the difference between the Number of enrolments of both sexes in Secondary in 1991 and the Number of enrolments of both sexes in Secondary general in 1992?
Your response must be concise. 2.42e+04. What is the difference between the Number of enrolments of both sexes of Secondary in 1991 and the Number of enrolments of both sexes of Secondary vocational in 1992?
Your answer should be very brief. 5.66e+05. What is the difference between the Number of enrolments of both sexes in Secondary general in 1991 and the Number of enrolments of both sexes in Secondary vocational in 1992?
Your response must be concise. 5.10e+05. What is the difference between the Number of enrolments of both sexes in Primary in 1991 and the Number of enrolments of both sexes in Secondary in 1993?
Provide a succinct answer. 1.54e+06. What is the difference between the Number of enrolments of both sexes of Primary in 1991 and the Number of enrolments of both sexes of Secondary general in 1993?
Give a very brief answer. 1.59e+06. What is the difference between the Number of enrolments of both sexes of Primary in 1991 and the Number of enrolments of both sexes of Secondary vocational in 1993?
Offer a very short reply. 2.17e+06. What is the difference between the Number of enrolments of both sexes in Secondary in 1991 and the Number of enrolments of both sexes in Secondary general in 1993?
Your answer should be compact. -1.20e+04. What is the difference between the Number of enrolments of both sexes in Secondary in 1991 and the Number of enrolments of both sexes in Secondary vocational in 1993?
Provide a short and direct response. 5.65e+05. What is the difference between the Number of enrolments of both sexes of Secondary general in 1991 and the Number of enrolments of both sexes of Secondary vocational in 1993?
Your response must be concise. 5.09e+05. What is the difference between the Number of enrolments of both sexes in Primary in 1992 and the Number of enrolments of both sexes in Secondary in 1993?
Make the answer very short. 1.58e+06. What is the difference between the Number of enrolments of both sexes in Primary in 1992 and the Number of enrolments of both sexes in Secondary general in 1993?
Offer a terse response. 1.63e+06. What is the difference between the Number of enrolments of both sexes in Primary in 1992 and the Number of enrolments of both sexes in Secondary vocational in 1993?
Provide a succinct answer. 2.21e+06. What is the difference between the Number of enrolments of both sexes in Secondary in 1992 and the Number of enrolments of both sexes in Secondary general in 1993?
Your answer should be very brief. 1.95e+04. What is the difference between the Number of enrolments of both sexes of Secondary in 1992 and the Number of enrolments of both sexes of Secondary vocational in 1993?
Your response must be concise. 5.97e+05. What is the difference between the Number of enrolments of both sexes in Secondary general in 1992 and the Number of enrolments of both sexes in Secondary vocational in 1993?
Give a very brief answer. 5.41e+05. What is the average Number of enrolments of both sexes of Primary per year?
Your answer should be compact. 2.13e+06. What is the average Number of enrolments of both sexes in Secondary per year?
Offer a terse response. 5.75e+05. What is the average Number of enrolments of both sexes of Secondary general per year?
Your answer should be compact. 5.19e+05. What is the average Number of enrolments of both sexes of Secondary vocational per year?
Ensure brevity in your answer.  5.65e+04. In the year 1986, what is the difference between the Number of enrolments of both sexes in Primary and Number of enrolments of both sexes in Secondary?
Provide a short and direct response. 1.46e+06. In the year 1986, what is the difference between the Number of enrolments of both sexes in Primary and Number of enrolments of both sexes in Secondary general?
Your answer should be very brief. 1.52e+06. In the year 1986, what is the difference between the Number of enrolments of both sexes of Primary and Number of enrolments of both sexes of Secondary vocational?
Make the answer very short. 1.88e+06. In the year 1986, what is the difference between the Number of enrolments of both sexes in Secondary and Number of enrolments of both sexes in Secondary general?
Your answer should be very brief. 5.83e+04. In the year 1986, what is the difference between the Number of enrolments of both sexes in Secondary and Number of enrolments of both sexes in Secondary vocational?
Keep it short and to the point. 4.25e+05. In the year 1986, what is the difference between the Number of enrolments of both sexes of Secondary general and Number of enrolments of both sexes of Secondary vocational?
Your response must be concise. 3.67e+05. In the year 1987, what is the difference between the Number of enrolments of both sexes in Primary and Number of enrolments of both sexes in Secondary?
Give a very brief answer. 1.50e+06. In the year 1987, what is the difference between the Number of enrolments of both sexes of Primary and Number of enrolments of both sexes of Secondary general?
Make the answer very short. 1.55e+06. In the year 1987, what is the difference between the Number of enrolments of both sexes in Primary and Number of enrolments of both sexes in Secondary vocational?
Your answer should be very brief. 1.94e+06. In the year 1987, what is the difference between the Number of enrolments of both sexes of Secondary and Number of enrolments of both sexes of Secondary general?
Your answer should be compact. 5.69e+04. In the year 1987, what is the difference between the Number of enrolments of both sexes of Secondary and Number of enrolments of both sexes of Secondary vocational?
Ensure brevity in your answer.  4.45e+05. In the year 1987, what is the difference between the Number of enrolments of both sexes of Secondary general and Number of enrolments of both sexes of Secondary vocational?
Ensure brevity in your answer.  3.88e+05. In the year 1988, what is the difference between the Number of enrolments of both sexes of Primary and Number of enrolments of both sexes of Secondary?
Give a very brief answer. 1.52e+06. In the year 1988, what is the difference between the Number of enrolments of both sexes in Primary and Number of enrolments of both sexes in Secondary general?
Your answer should be compact. 1.58e+06. In the year 1988, what is the difference between the Number of enrolments of both sexes of Primary and Number of enrolments of both sexes of Secondary vocational?
Ensure brevity in your answer.  1.99e+06. In the year 1988, what is the difference between the Number of enrolments of both sexes in Secondary and Number of enrolments of both sexes in Secondary general?
Provide a succinct answer. 5.89e+04. In the year 1988, what is the difference between the Number of enrolments of both sexes of Secondary and Number of enrolments of both sexes of Secondary vocational?
Offer a terse response. 4.66e+05. In the year 1988, what is the difference between the Number of enrolments of both sexes of Secondary general and Number of enrolments of both sexes of Secondary vocational?
Give a very brief answer. 4.07e+05. In the year 1989, what is the difference between the Number of enrolments of both sexes in Primary and Number of enrolments of both sexes in Secondary?
Give a very brief answer. 1.54e+06. In the year 1989, what is the difference between the Number of enrolments of both sexes in Primary and Number of enrolments of both sexes in Secondary general?
Give a very brief answer. 1.59e+06. In the year 1989, what is the difference between the Number of enrolments of both sexes of Primary and Number of enrolments of both sexes of Secondary vocational?
Keep it short and to the point. 2.03e+06. In the year 1989, what is the difference between the Number of enrolments of both sexes of Secondary and Number of enrolments of both sexes of Secondary general?
Your response must be concise. 5.49e+04. In the year 1989, what is the difference between the Number of enrolments of both sexes of Secondary and Number of enrolments of both sexes of Secondary vocational?
Give a very brief answer. 4.97e+05. In the year 1989, what is the difference between the Number of enrolments of both sexes in Secondary general and Number of enrolments of both sexes in Secondary vocational?
Offer a terse response. 4.42e+05. In the year 1990, what is the difference between the Number of enrolments of both sexes in Primary and Number of enrolments of both sexes in Secondary?
Provide a short and direct response. 1.56e+06. In the year 1990, what is the difference between the Number of enrolments of both sexes in Primary and Number of enrolments of both sexes in Secondary general?
Provide a short and direct response. 1.62e+06. In the year 1990, what is the difference between the Number of enrolments of both sexes in Primary and Number of enrolments of both sexes in Secondary vocational?
Offer a very short reply. 2.08e+06. In the year 1990, what is the difference between the Number of enrolments of both sexes of Secondary and Number of enrolments of both sexes of Secondary general?
Give a very brief answer. 5.59e+04. In the year 1990, what is the difference between the Number of enrolments of both sexes of Secondary and Number of enrolments of both sexes of Secondary vocational?
Make the answer very short. 5.21e+05. In the year 1990, what is the difference between the Number of enrolments of both sexes in Secondary general and Number of enrolments of both sexes in Secondary vocational?
Offer a terse response. 4.65e+05. In the year 1991, what is the difference between the Number of enrolments of both sexes in Primary and Number of enrolments of both sexes in Secondary?
Provide a succinct answer. 1.60e+06. In the year 1991, what is the difference between the Number of enrolments of both sexes in Primary and Number of enrolments of both sexes in Secondary general?
Offer a terse response. 1.66e+06. In the year 1991, what is the difference between the Number of enrolments of both sexes in Primary and Number of enrolments of both sexes in Secondary vocational?
Ensure brevity in your answer.  2.17e+06. In the year 1991, what is the difference between the Number of enrolments of both sexes in Secondary and Number of enrolments of both sexes in Secondary general?
Your answer should be compact. 5.59e+04. In the year 1991, what is the difference between the Number of enrolments of both sexes in Secondary and Number of enrolments of both sexes in Secondary vocational?
Give a very brief answer. 5.65e+05. In the year 1991, what is the difference between the Number of enrolments of both sexes of Secondary general and Number of enrolments of both sexes of Secondary vocational?
Offer a very short reply. 5.09e+05. In the year 1992, what is the difference between the Number of enrolments of both sexes of Primary and Number of enrolments of both sexes of Secondary?
Your answer should be very brief. 1.61e+06. In the year 1992, what is the difference between the Number of enrolments of both sexes of Primary and Number of enrolments of both sexes of Secondary general?
Keep it short and to the point. 1.67e+06. In the year 1992, what is the difference between the Number of enrolments of both sexes of Primary and Number of enrolments of both sexes of Secondary vocational?
Provide a short and direct response. 2.21e+06. In the year 1992, what is the difference between the Number of enrolments of both sexes in Secondary and Number of enrolments of both sexes in Secondary general?
Your answer should be very brief. 5.57e+04. In the year 1992, what is the difference between the Number of enrolments of both sexes of Secondary and Number of enrolments of both sexes of Secondary vocational?
Provide a succinct answer. 5.97e+05. In the year 1992, what is the difference between the Number of enrolments of both sexes of Secondary general and Number of enrolments of both sexes of Secondary vocational?
Offer a very short reply. 5.41e+05. In the year 1993, what is the difference between the Number of enrolments of both sexes of Primary and Number of enrolments of both sexes of Secondary?
Keep it short and to the point. 1.61e+06. In the year 1993, what is the difference between the Number of enrolments of both sexes in Primary and Number of enrolments of both sexes in Secondary general?
Give a very brief answer. 1.67e+06. In the year 1993, what is the difference between the Number of enrolments of both sexes of Primary and Number of enrolments of both sexes of Secondary vocational?
Your answer should be very brief. 2.25e+06. In the year 1993, what is the difference between the Number of enrolments of both sexes of Secondary and Number of enrolments of both sexes of Secondary general?
Offer a terse response. 5.59e+04. In the year 1993, what is the difference between the Number of enrolments of both sexes of Secondary and Number of enrolments of both sexes of Secondary vocational?
Make the answer very short. 6.33e+05. In the year 1993, what is the difference between the Number of enrolments of both sexes of Secondary general and Number of enrolments of both sexes of Secondary vocational?
Your answer should be compact. 5.77e+05. What is the ratio of the Number of enrolments of both sexes in Secondary in 1986 to that in 1987?
Provide a succinct answer. 0.96. What is the ratio of the Number of enrolments of both sexes of Secondary general in 1986 to that in 1987?
Offer a terse response. 0.96. What is the ratio of the Number of enrolments of both sexes in Secondary vocational in 1986 to that in 1987?
Offer a very short reply. 1.02. What is the ratio of the Number of enrolments of both sexes in Primary in 1986 to that in 1988?
Keep it short and to the point. 0.95. What is the ratio of the Number of enrolments of both sexes in Secondary in 1986 to that in 1988?
Your answer should be very brief. 0.92. What is the ratio of the Number of enrolments of both sexes of Secondary general in 1986 to that in 1988?
Your answer should be very brief. 0.91. What is the ratio of the Number of enrolments of both sexes in Primary in 1986 to that in 1989?
Offer a terse response. 0.93. What is the ratio of the Number of enrolments of both sexes in Secondary in 1986 to that in 1989?
Offer a terse response. 0.88. What is the ratio of the Number of enrolments of both sexes in Secondary general in 1986 to that in 1989?
Give a very brief answer. 0.86. What is the ratio of the Number of enrolments of both sexes of Secondary vocational in 1986 to that in 1989?
Your answer should be very brief. 1.06. What is the ratio of the Number of enrolments of both sexes in Primary in 1986 to that in 1990?
Offer a very short reply. 0.91. What is the ratio of the Number of enrolments of both sexes of Secondary in 1986 to that in 1990?
Your answer should be compact. 0.84. What is the ratio of the Number of enrolments of both sexes in Secondary general in 1986 to that in 1990?
Provide a succinct answer. 0.82. What is the ratio of the Number of enrolments of both sexes of Secondary vocational in 1986 to that in 1990?
Your answer should be compact. 1.04. What is the ratio of the Number of enrolments of both sexes in Primary in 1986 to that in 1991?
Offer a very short reply. 0.87. What is the ratio of the Number of enrolments of both sexes in Secondary in 1986 to that in 1991?
Offer a very short reply. 0.78. What is the ratio of the Number of enrolments of both sexes in Secondary general in 1986 to that in 1991?
Keep it short and to the point. 0.75. What is the ratio of the Number of enrolments of both sexes of Secondary vocational in 1986 to that in 1991?
Your response must be concise. 1.04. What is the ratio of the Number of enrolments of both sexes in Primary in 1986 to that in 1992?
Offer a very short reply. 0.86. What is the ratio of the Number of enrolments of both sexes in Secondary in 1986 to that in 1992?
Offer a terse response. 0.74. What is the ratio of the Number of enrolments of both sexes of Secondary general in 1986 to that in 1992?
Your answer should be very brief. 0.71. What is the ratio of the Number of enrolments of both sexes of Secondary vocational in 1986 to that in 1992?
Offer a very short reply. 1.05. What is the ratio of the Number of enrolments of both sexes in Primary in 1986 to that in 1993?
Ensure brevity in your answer.  0.84. What is the ratio of the Number of enrolments of both sexes in Secondary in 1986 to that in 1993?
Your answer should be compact. 0.7. What is the ratio of the Number of enrolments of both sexes of Secondary general in 1986 to that in 1993?
Give a very brief answer. 0.67. What is the ratio of the Number of enrolments of both sexes in Secondary vocational in 1986 to that in 1993?
Make the answer very short. 1.04. What is the ratio of the Number of enrolments of both sexes in Primary in 1987 to that in 1988?
Offer a very short reply. 0.98. What is the ratio of the Number of enrolments of both sexes in Secondary in 1987 to that in 1988?
Give a very brief answer. 0.96. What is the ratio of the Number of enrolments of both sexes in Secondary general in 1987 to that in 1988?
Give a very brief answer. 0.95. What is the ratio of the Number of enrolments of both sexes in Secondary vocational in 1987 to that in 1988?
Make the answer very short. 0.97. What is the ratio of the Number of enrolments of both sexes of Primary in 1987 to that in 1989?
Your answer should be compact. 0.96. What is the ratio of the Number of enrolments of both sexes of Secondary in 1987 to that in 1989?
Ensure brevity in your answer.  0.91. What is the ratio of the Number of enrolments of both sexes of Secondary general in 1987 to that in 1989?
Keep it short and to the point. 0.89. What is the ratio of the Number of enrolments of both sexes of Secondary vocational in 1987 to that in 1989?
Provide a succinct answer. 1.04. What is the ratio of the Number of enrolments of both sexes of Primary in 1987 to that in 1990?
Your response must be concise. 0.94. What is the ratio of the Number of enrolments of both sexes of Secondary in 1987 to that in 1990?
Your answer should be compact. 0.87. What is the ratio of the Number of enrolments of both sexes of Secondary general in 1987 to that in 1990?
Provide a short and direct response. 0.85. What is the ratio of the Number of enrolments of both sexes of Secondary vocational in 1987 to that in 1990?
Your response must be concise. 1.02. What is the ratio of the Number of enrolments of both sexes of Primary in 1987 to that in 1991?
Offer a terse response. 0.9. What is the ratio of the Number of enrolments of both sexes in Secondary in 1987 to that in 1991?
Your answer should be compact. 0.81. What is the ratio of the Number of enrolments of both sexes of Secondary general in 1987 to that in 1991?
Your answer should be compact. 0.79. What is the ratio of the Number of enrolments of both sexes in Primary in 1987 to that in 1992?
Make the answer very short. 0.88. What is the ratio of the Number of enrolments of both sexes of Secondary in 1987 to that in 1992?
Offer a terse response. 0.77. What is the ratio of the Number of enrolments of both sexes in Secondary general in 1987 to that in 1992?
Your answer should be compact. 0.75. What is the ratio of the Number of enrolments of both sexes of Secondary vocational in 1987 to that in 1992?
Give a very brief answer. 1.02. What is the ratio of the Number of enrolments of both sexes of Primary in 1987 to that in 1993?
Your answer should be compact. 0.87. What is the ratio of the Number of enrolments of both sexes in Secondary in 1987 to that in 1993?
Your response must be concise. 0.73. What is the ratio of the Number of enrolments of both sexes of Secondary general in 1987 to that in 1993?
Offer a terse response. 0.7. What is the ratio of the Number of enrolments of both sexes in Secondary vocational in 1987 to that in 1993?
Give a very brief answer. 1.02. What is the ratio of the Number of enrolments of both sexes in Primary in 1988 to that in 1989?
Your answer should be compact. 0.98. What is the ratio of the Number of enrolments of both sexes of Secondary in 1988 to that in 1989?
Your answer should be compact. 0.95. What is the ratio of the Number of enrolments of both sexes in Secondary general in 1988 to that in 1989?
Keep it short and to the point. 0.94. What is the ratio of the Number of enrolments of both sexes of Secondary vocational in 1988 to that in 1989?
Provide a short and direct response. 1.07. What is the ratio of the Number of enrolments of both sexes in Primary in 1988 to that in 1990?
Keep it short and to the point. 0.96. What is the ratio of the Number of enrolments of both sexes of Secondary in 1988 to that in 1990?
Provide a succinct answer. 0.91. What is the ratio of the Number of enrolments of both sexes in Secondary general in 1988 to that in 1990?
Offer a very short reply. 0.89. What is the ratio of the Number of enrolments of both sexes of Secondary vocational in 1988 to that in 1990?
Your response must be concise. 1.05. What is the ratio of the Number of enrolments of both sexes of Primary in 1988 to that in 1991?
Offer a terse response. 0.92. What is the ratio of the Number of enrolments of both sexes of Secondary in 1988 to that in 1991?
Keep it short and to the point. 0.85. What is the ratio of the Number of enrolments of both sexes of Secondary general in 1988 to that in 1991?
Ensure brevity in your answer.  0.82. What is the ratio of the Number of enrolments of both sexes of Secondary vocational in 1988 to that in 1991?
Your answer should be compact. 1.05. What is the ratio of the Number of enrolments of both sexes in Primary in 1988 to that in 1992?
Offer a terse response. 0.9. What is the ratio of the Number of enrolments of both sexes in Secondary in 1988 to that in 1992?
Provide a succinct answer. 0.8. What is the ratio of the Number of enrolments of both sexes of Secondary general in 1988 to that in 1992?
Your answer should be very brief. 0.78. What is the ratio of the Number of enrolments of both sexes of Secondary vocational in 1988 to that in 1992?
Your answer should be very brief. 1.06. What is the ratio of the Number of enrolments of both sexes in Primary in 1988 to that in 1993?
Provide a succinct answer. 0.89. What is the ratio of the Number of enrolments of both sexes of Secondary in 1988 to that in 1993?
Your answer should be very brief. 0.76. What is the ratio of the Number of enrolments of both sexes of Secondary general in 1988 to that in 1993?
Your response must be concise. 0.74. What is the ratio of the Number of enrolments of both sexes in Secondary vocational in 1988 to that in 1993?
Your answer should be very brief. 1.05. What is the ratio of the Number of enrolments of both sexes in Primary in 1989 to that in 1990?
Your answer should be very brief. 0.98. What is the ratio of the Number of enrolments of both sexes in Secondary in 1989 to that in 1990?
Give a very brief answer. 0.96. What is the ratio of the Number of enrolments of both sexes of Secondary general in 1989 to that in 1990?
Give a very brief answer. 0.95. What is the ratio of the Number of enrolments of both sexes of Secondary vocational in 1989 to that in 1990?
Your answer should be very brief. 0.98. What is the ratio of the Number of enrolments of both sexes of Primary in 1989 to that in 1991?
Offer a very short reply. 0.94. What is the ratio of the Number of enrolments of both sexes in Secondary in 1989 to that in 1991?
Keep it short and to the point. 0.89. What is the ratio of the Number of enrolments of both sexes of Secondary general in 1989 to that in 1991?
Your response must be concise. 0.88. What is the ratio of the Number of enrolments of both sexes in Secondary vocational in 1989 to that in 1991?
Your answer should be compact. 0.98. What is the ratio of the Number of enrolments of both sexes in Primary in 1989 to that in 1992?
Offer a very short reply. 0.92. What is the ratio of the Number of enrolments of both sexes of Secondary in 1989 to that in 1992?
Provide a short and direct response. 0.85. What is the ratio of the Number of enrolments of both sexes of Secondary general in 1989 to that in 1992?
Make the answer very short. 0.83. What is the ratio of the Number of enrolments of both sexes in Secondary vocational in 1989 to that in 1992?
Your answer should be very brief. 0.99. What is the ratio of the Number of enrolments of both sexes in Primary in 1989 to that in 1993?
Offer a terse response. 0.91. What is the ratio of the Number of enrolments of both sexes of Secondary in 1989 to that in 1993?
Your answer should be very brief. 0.8. What is the ratio of the Number of enrolments of both sexes in Secondary general in 1989 to that in 1993?
Your answer should be compact. 0.79. What is the ratio of the Number of enrolments of both sexes of Secondary vocational in 1989 to that in 1993?
Keep it short and to the point. 0.98. What is the ratio of the Number of enrolments of both sexes in Primary in 1990 to that in 1991?
Your answer should be compact. 0.96. What is the ratio of the Number of enrolments of both sexes of Secondary in 1990 to that in 1991?
Make the answer very short. 0.93. What is the ratio of the Number of enrolments of both sexes in Secondary general in 1990 to that in 1991?
Provide a succinct answer. 0.92. What is the ratio of the Number of enrolments of both sexes in Secondary vocational in 1990 to that in 1991?
Give a very brief answer. 1. What is the ratio of the Number of enrolments of both sexes in Primary in 1990 to that in 1992?
Offer a very short reply. 0.94. What is the ratio of the Number of enrolments of both sexes in Secondary in 1990 to that in 1992?
Give a very brief answer. 0.88. What is the ratio of the Number of enrolments of both sexes of Secondary general in 1990 to that in 1992?
Give a very brief answer. 0.87. What is the ratio of the Number of enrolments of both sexes in Primary in 1990 to that in 1993?
Provide a succinct answer. 0.93. What is the ratio of the Number of enrolments of both sexes in Secondary in 1990 to that in 1993?
Give a very brief answer. 0.84. What is the ratio of the Number of enrolments of both sexes of Secondary general in 1990 to that in 1993?
Offer a terse response. 0.82. What is the ratio of the Number of enrolments of both sexes in Secondary vocational in 1990 to that in 1993?
Offer a very short reply. 1. What is the ratio of the Number of enrolments of both sexes in Primary in 1991 to that in 1992?
Your response must be concise. 0.98. What is the ratio of the Number of enrolments of both sexes of Secondary in 1991 to that in 1992?
Your response must be concise. 0.95. What is the ratio of the Number of enrolments of both sexes of Secondary general in 1991 to that in 1992?
Provide a succinct answer. 0.95. What is the ratio of the Number of enrolments of both sexes of Secondary vocational in 1991 to that in 1992?
Ensure brevity in your answer.  1. What is the ratio of the Number of enrolments of both sexes in Primary in 1991 to that in 1993?
Offer a terse response. 0.97. What is the ratio of the Number of enrolments of both sexes of Secondary in 1991 to that in 1993?
Provide a succinct answer. 0.9. What is the ratio of the Number of enrolments of both sexes in Secondary general in 1991 to that in 1993?
Provide a succinct answer. 0.89. What is the ratio of the Number of enrolments of both sexes of Secondary vocational in 1991 to that in 1993?
Your response must be concise. 1. What is the ratio of the Number of enrolments of both sexes of Primary in 1992 to that in 1993?
Keep it short and to the point. 0.98. What is the ratio of the Number of enrolments of both sexes of Secondary in 1992 to that in 1993?
Provide a succinct answer. 0.95. What is the ratio of the Number of enrolments of both sexes of Secondary general in 1992 to that in 1993?
Provide a short and direct response. 0.94. What is the difference between the highest and the second highest Number of enrolments of both sexes in Primary?
Offer a terse response. 3.69e+04. What is the difference between the highest and the second highest Number of enrolments of both sexes in Secondary?
Offer a very short reply. 3.64e+04. What is the difference between the highest and the second highest Number of enrolments of both sexes of Secondary general?
Your answer should be very brief. 3.62e+04. What is the difference between the highest and the second highest Number of enrolments of both sexes in Secondary vocational?
Your answer should be very brief. 603.38. What is the difference between the highest and the lowest Number of enrolments of both sexes in Primary?
Offer a terse response. 3.60e+05. What is the difference between the highest and the lowest Number of enrolments of both sexes in Secondary?
Your response must be concise. 2.05e+05. What is the difference between the highest and the lowest Number of enrolments of both sexes in Secondary general?
Your response must be concise. 2.08e+05. What is the difference between the highest and the lowest Number of enrolments of both sexes of Secondary vocational?
Offer a very short reply. 3942.82. 